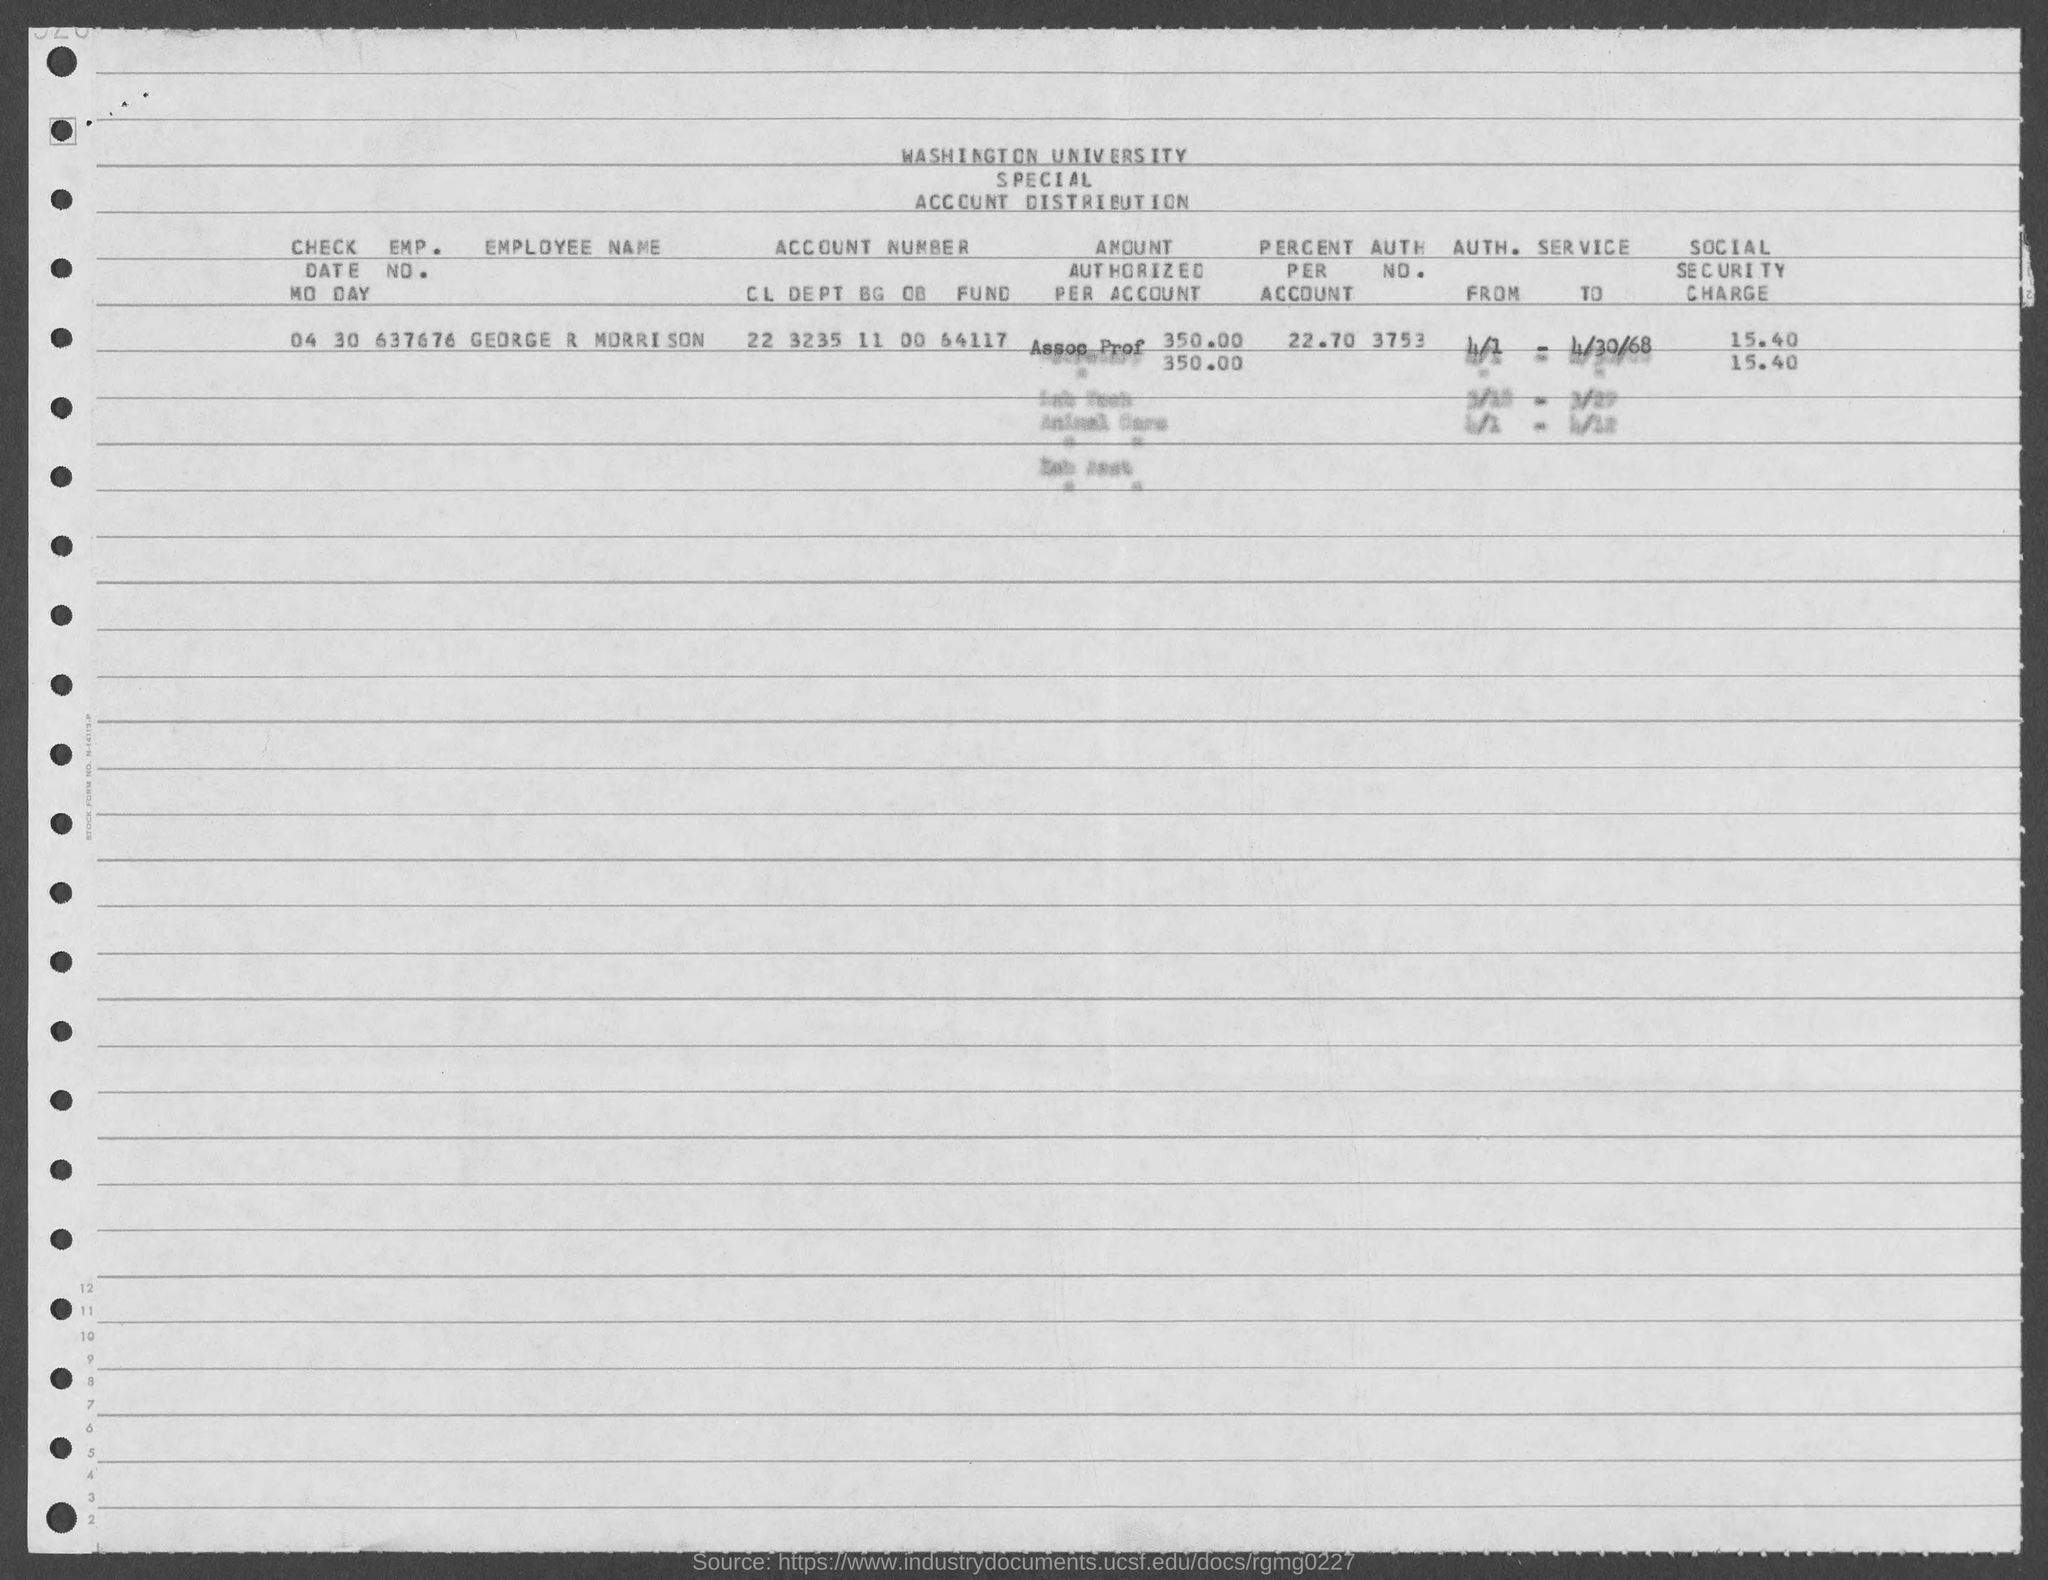Highlight a few significant elements in this photo. The emp. no. of George R Morrison is 637676. What is the check date for the 30th of March? George R Morrison's account has 22.70%. 